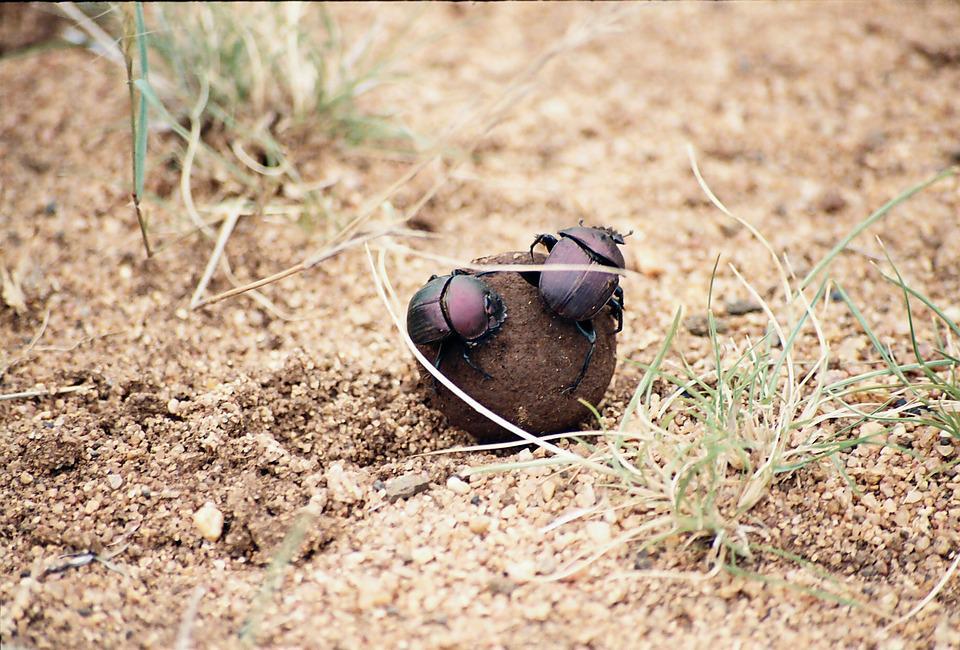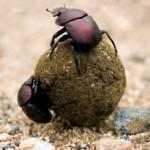The first image is the image on the left, the second image is the image on the right. Given the left and right images, does the statement "In each image, there are two beetles holding a dungball.›" hold true? Answer yes or no. Yes. The first image is the image on the left, the second image is the image on the right. Assess this claim about the two images: "The right image has two beetles pushing a dung ball.". Correct or not? Answer yes or no. Yes. 